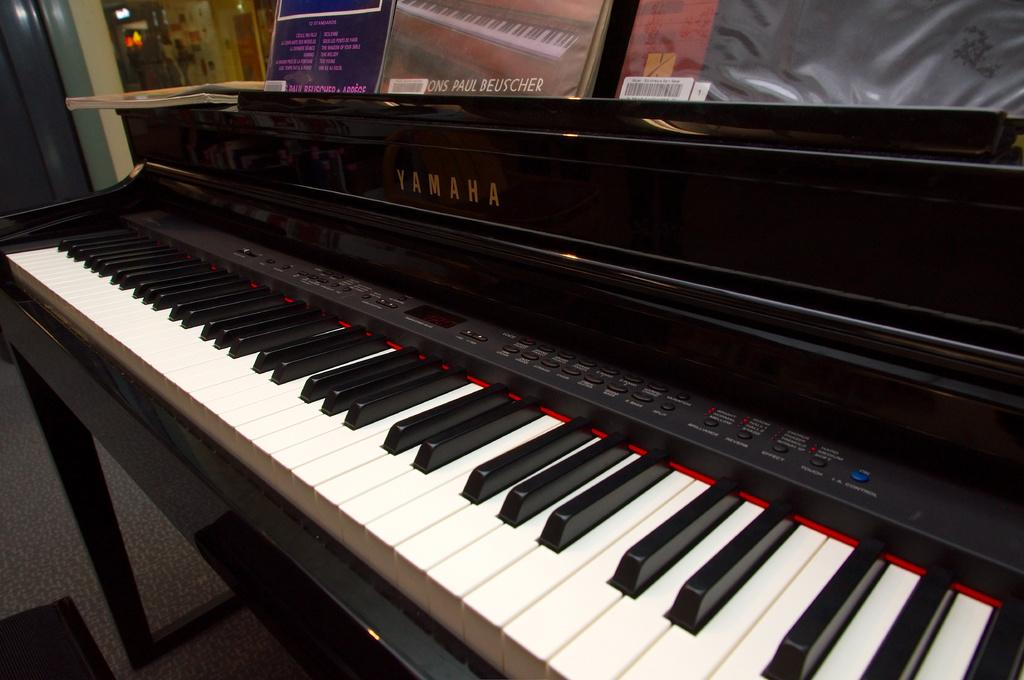What musical instrument is present in the image? There is a piano in the image. What part of the piano is used for playing music? The piano has a keyboard, which is used for playing music. What are the small buttons on the keyboard called? The small buttons on the keyboard are called keys. What is written or printed on the piano? There is text on the piano. What else can be seen on top of the piano? Some books are placed on top of the piano. How many snails are crawling on the piano keys in the image? There are no snails present in the image; it features related to the piano and its components are described. 